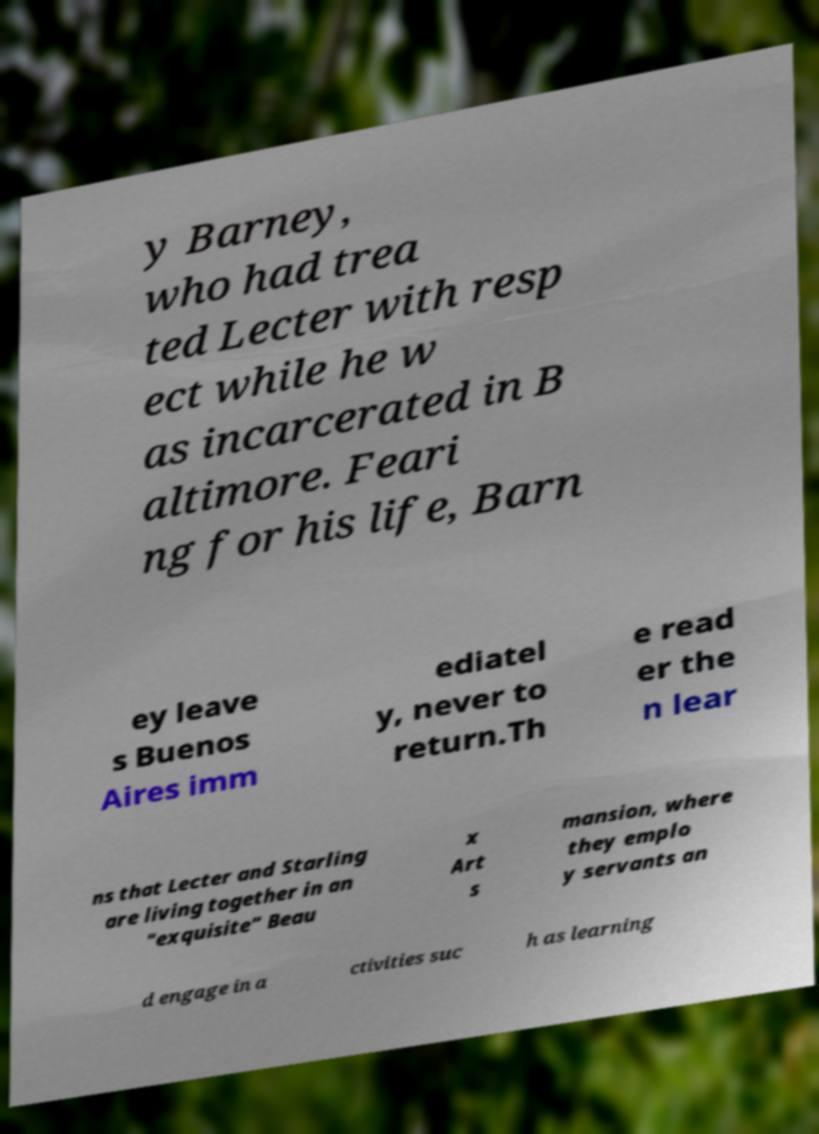Please read and relay the text visible in this image. What does it say? y Barney, who had trea ted Lecter with resp ect while he w as incarcerated in B altimore. Feari ng for his life, Barn ey leave s Buenos Aires imm ediatel y, never to return.Th e read er the n lear ns that Lecter and Starling are living together in an "exquisite" Beau x Art s mansion, where they emplo y servants an d engage in a ctivities suc h as learning 